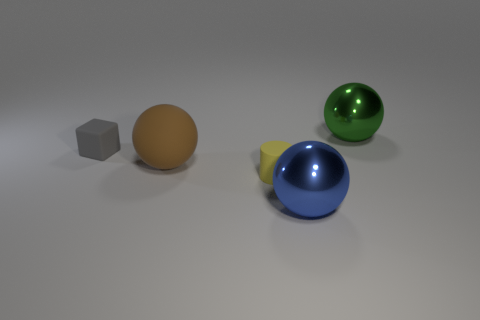Add 2 matte things. How many objects exist? 7 Subtract all gray spheres. Subtract all red cylinders. How many spheres are left? 3 Subtract all cylinders. How many objects are left? 4 Subtract 0 brown cubes. How many objects are left? 5 Subtract all large gray metallic blocks. Subtract all big blue metal things. How many objects are left? 4 Add 4 tiny matte cylinders. How many tiny matte cylinders are left? 5 Add 3 big brown matte spheres. How many big brown matte spheres exist? 4 